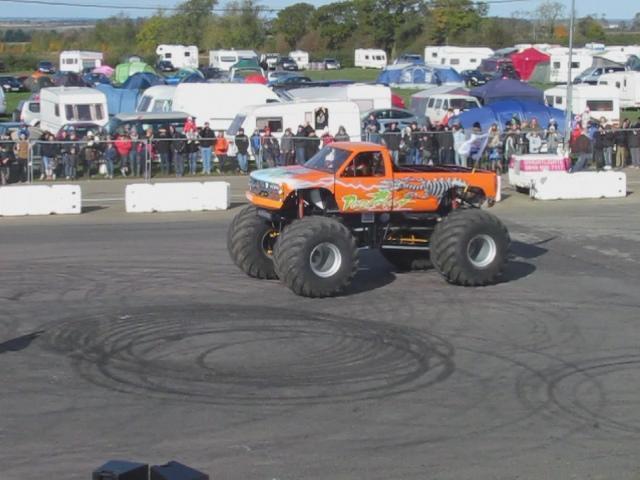What are the circular patterns on the ground?
Choose the correct response and explain in the format: 'Answer: answer
Rationale: rationale.'
Options: Abstract drawing, paint, tire tracks, cracks. Answer: tire tracks.
Rationale: The marks on the ground happen when something with rubber tires drives really fast in a circle and then brakes hard. What are the circular patterns on the ground?
Make your selection from the four choices given to correctly answer the question.
Options: Tire tracks, paint, abstract drawing, ink. Tire tracks. 